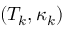<formula> <loc_0><loc_0><loc_500><loc_500>( T _ { k } , \kappa _ { k } )</formula> 